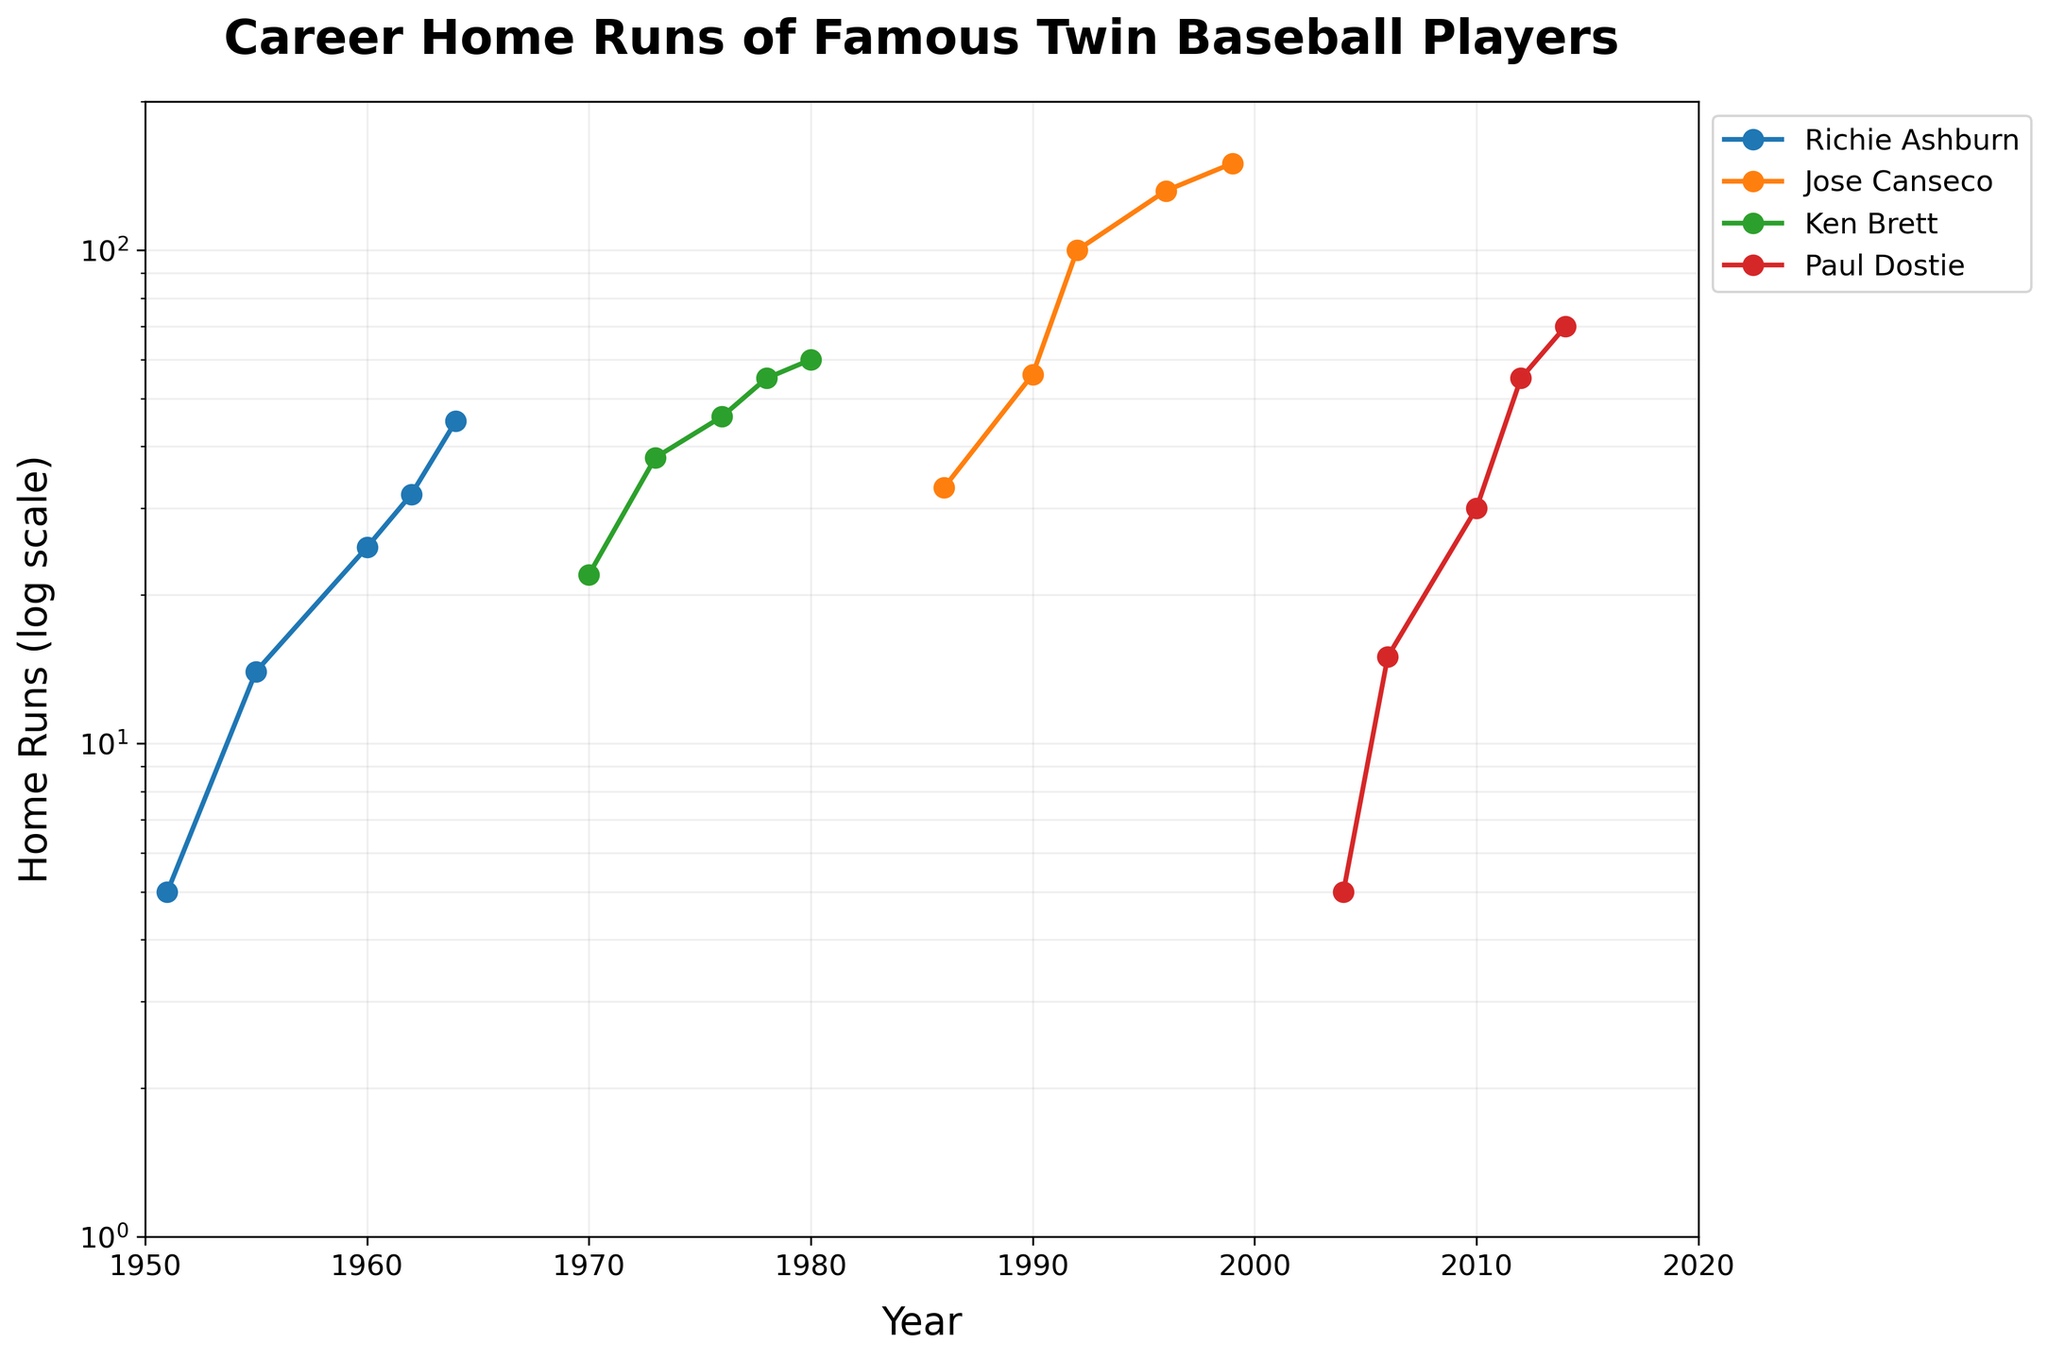1. What's the title of the figure? The title is located at the top of the plot and is displayed in bold letters. The title summarizes the content of the figure, which is about the career home runs of famous twin baseball players.
Answer: Career Home Runs of Famous Twin Baseball Players 2. How many unique players are shown in the figure? The legend on the right side of the plot shows one label for each unique player. Counting the labels gives the total number of unique players.
Answer: 4 3. Which player had the most home runs in 1996? Find the point in the figure corresponding to the year 1996 and compare the home run values. The player with the highest value is the answer.
Answer: Jose Canseco 4. Between 2004 and 2014, how did Paul Dostie's home runs change? Locate Paul Dostie's data points from 2004 to 2014. Note the corresponding home run values and determine the change in home runs between these years.
Answer: Increased 5. What is the range of years displayed on the x-axis? The range of the years can be determined by looking at the labels on the x-axis, which run from the first to the last year shown.
Answer: 1950 to 2020 6. In what year did Richie Ashburn reach 25 home runs? Trace Richie Ashburn's line to the point where it intersects with the 25 home run mark on the y-axis. Note the corresponding year.
Answer: 1960 7. Which player shows an exponential growth in their home runs according to the figure? An exponential growth pattern is characterized by a steep upward curve. Look for the player whose line shows a steep increase over time.
Answer: Paul Dostie 8. Compare Ken Brett's home run totals in 1970 and 1980. How much did it increase or decrease by? Identify Ken Brett's home run values in 1970 and 1980 from the plot, then subtract the value in 1970 from the value in 1980 to find the difference.
Answer: Increased by 38 9. Which player had their peak home run total in the 1960s? Observe the plot to find the player who had the highest home run total during the 1960s by looking at the y-axis values within this decade.
Answer: Richie Ashburn 10. Describe the general trend of Jose Canseco's career home runs over time. Observe the entire data line corresponding to Jose Canseco. Note whether the general direction of the line is increasing, decreasing, or fluctuating.
Answer: Increasing 